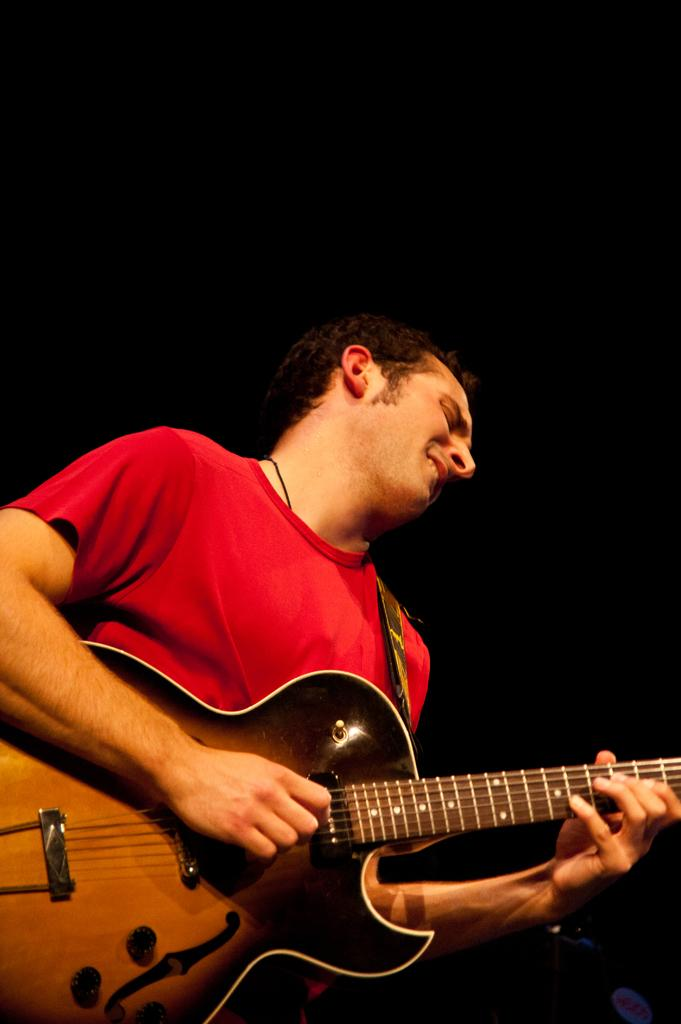What is the color of the background in the image? The background of the image is dark. Can you describe the person in the image? There is a person in the image, and they are wearing a red t-shirt. What is the person doing in the image? The person is standing and playing a guitar. What type of crown can be seen on the person's head in the image? There is no crown present on the person's head in the image. What season is depicted in the image? The provided facts do not mention any season or weather-related details. 